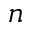Convert formula to latex. <formula><loc_0><loc_0><loc_500><loc_500>n</formula> 